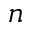Convert formula to latex. <formula><loc_0><loc_0><loc_500><loc_500>n</formula> 